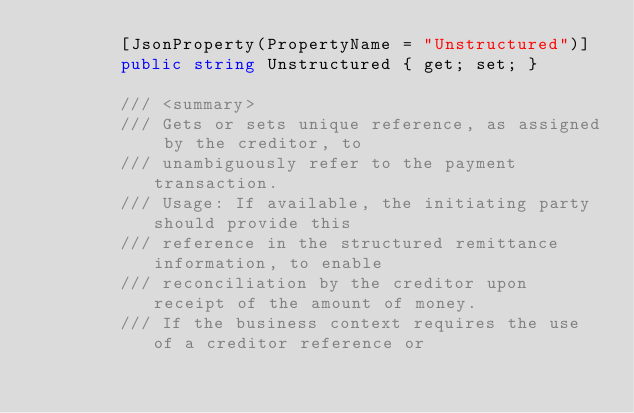Convert code to text. <code><loc_0><loc_0><loc_500><loc_500><_C#_>        [JsonProperty(PropertyName = "Unstructured")]
        public string Unstructured { get; set; }

        /// <summary>
        /// Gets or sets unique reference, as assigned by the creditor, to
        /// unambiguously refer to the payment transaction.
        /// Usage: If available, the initiating party should provide this
        /// reference in the structured remittance information, to enable
        /// reconciliation by the creditor upon receipt of the amount of money.
        /// If the business context requires the use of a creditor reference or</code> 